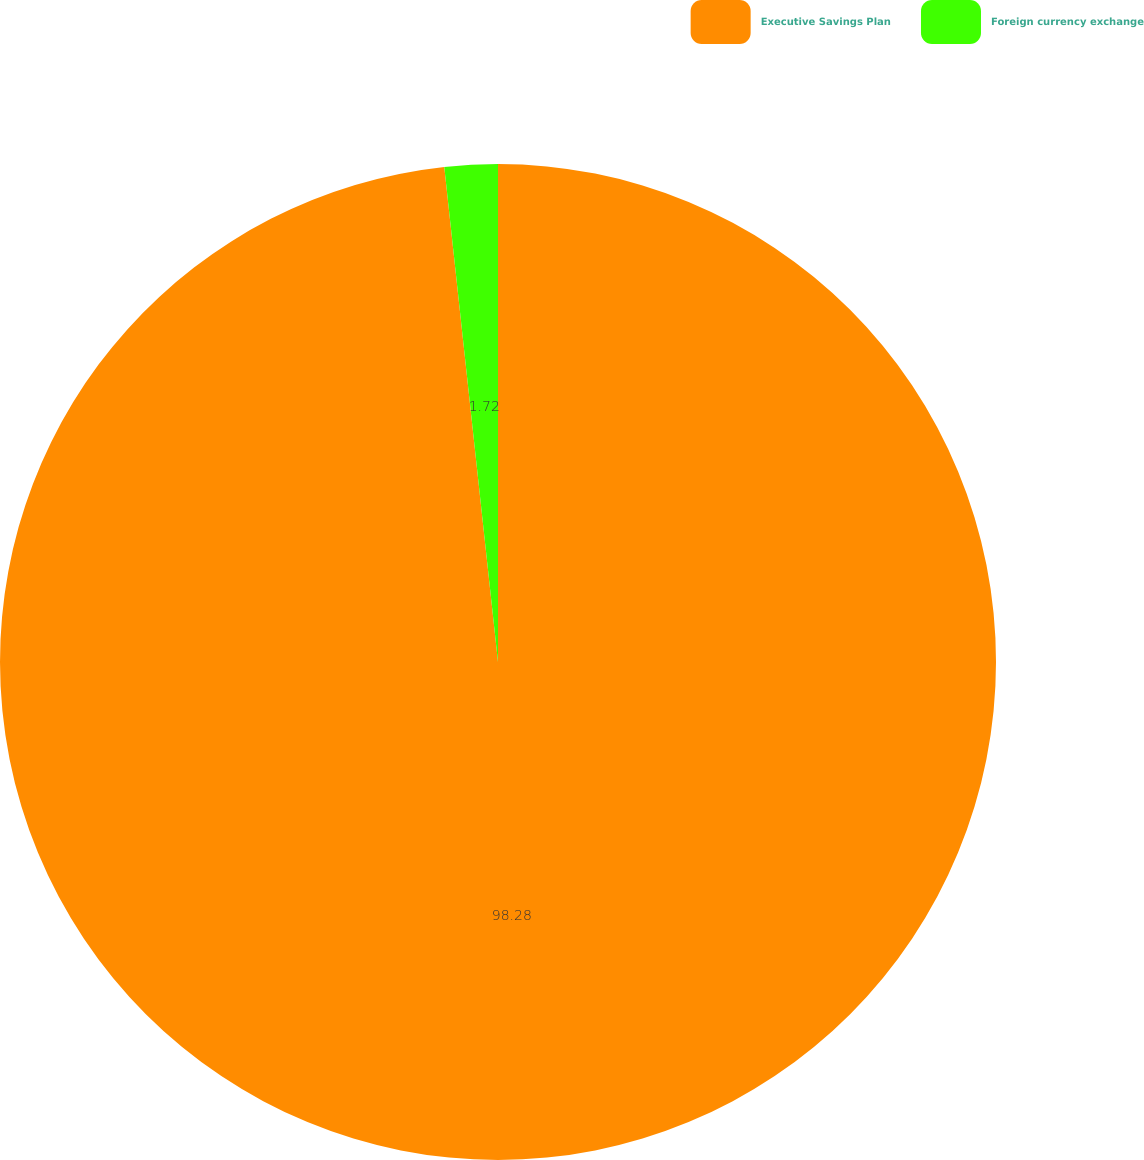Convert chart. <chart><loc_0><loc_0><loc_500><loc_500><pie_chart><fcel>Executive Savings Plan<fcel>Foreign currency exchange<nl><fcel>98.28%<fcel>1.72%<nl></chart> 